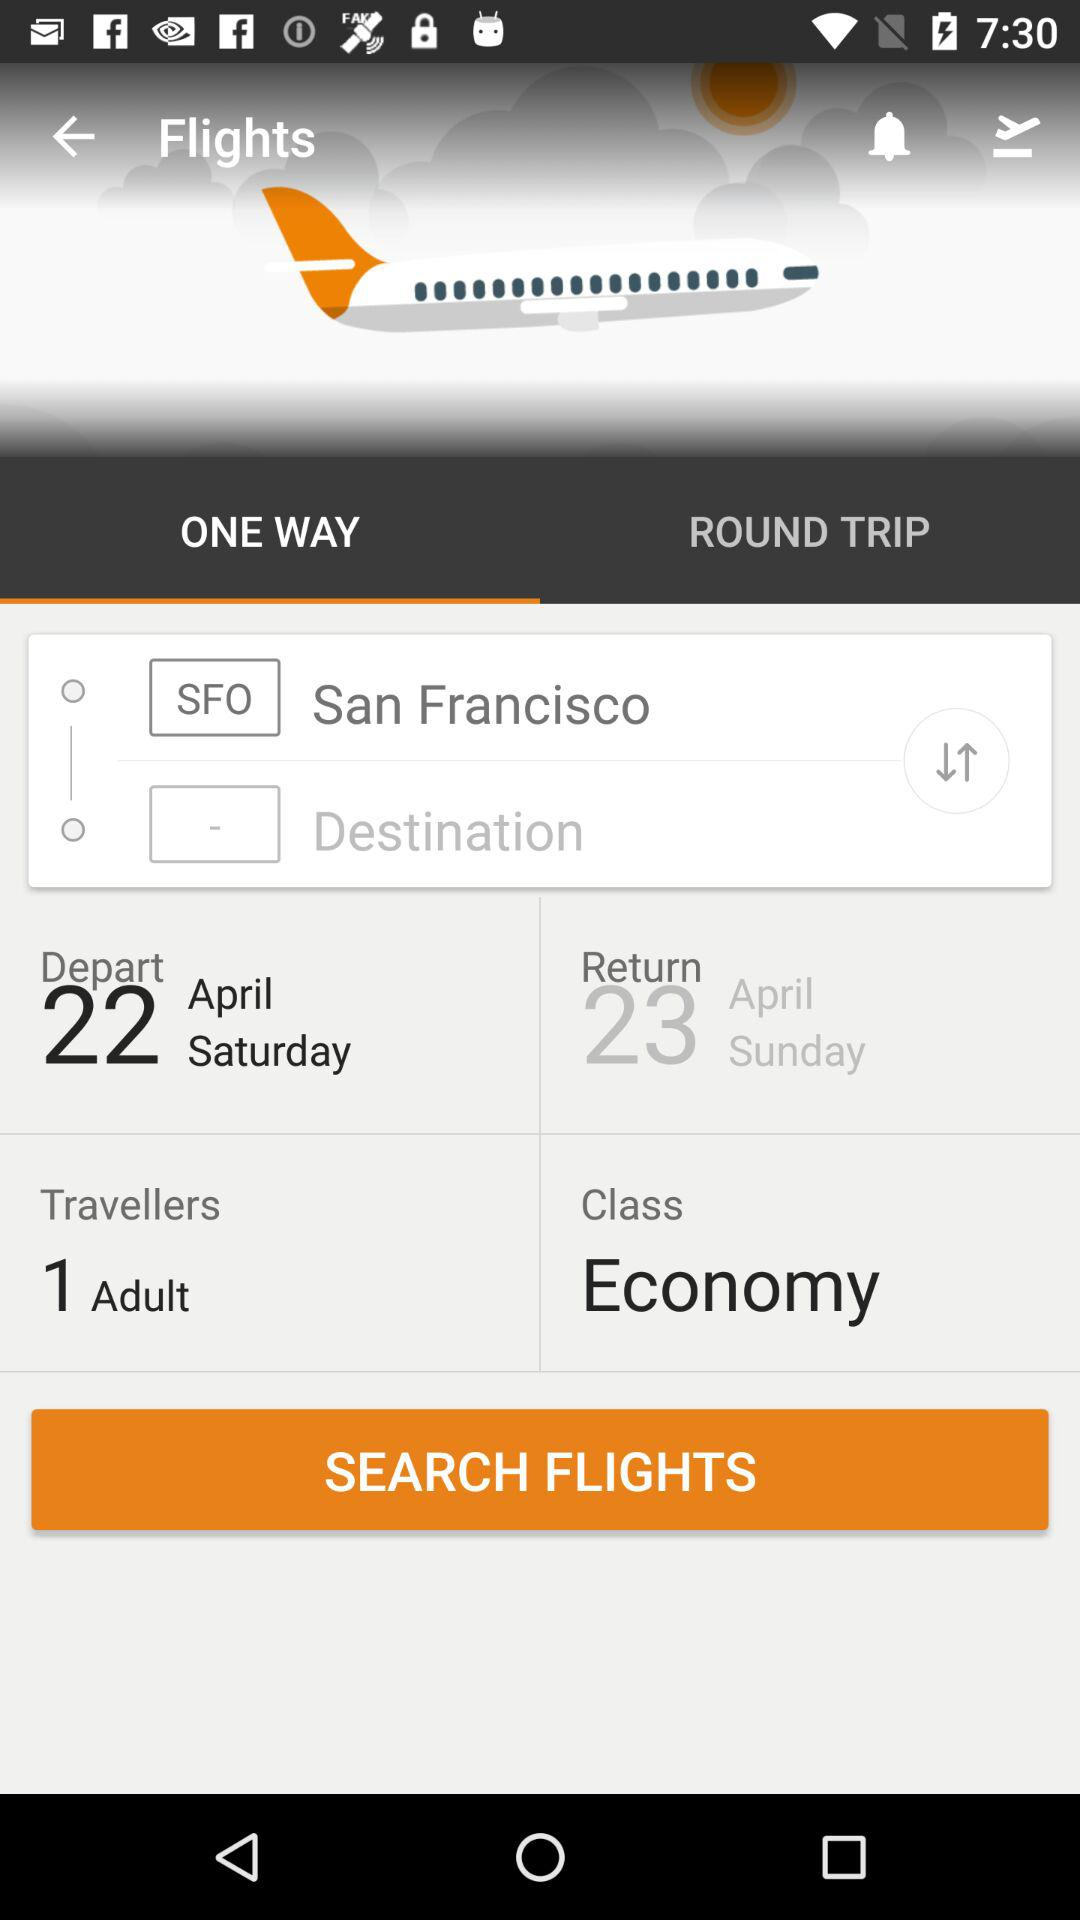What is the departure date? The departure date is Saturday, April 22. 